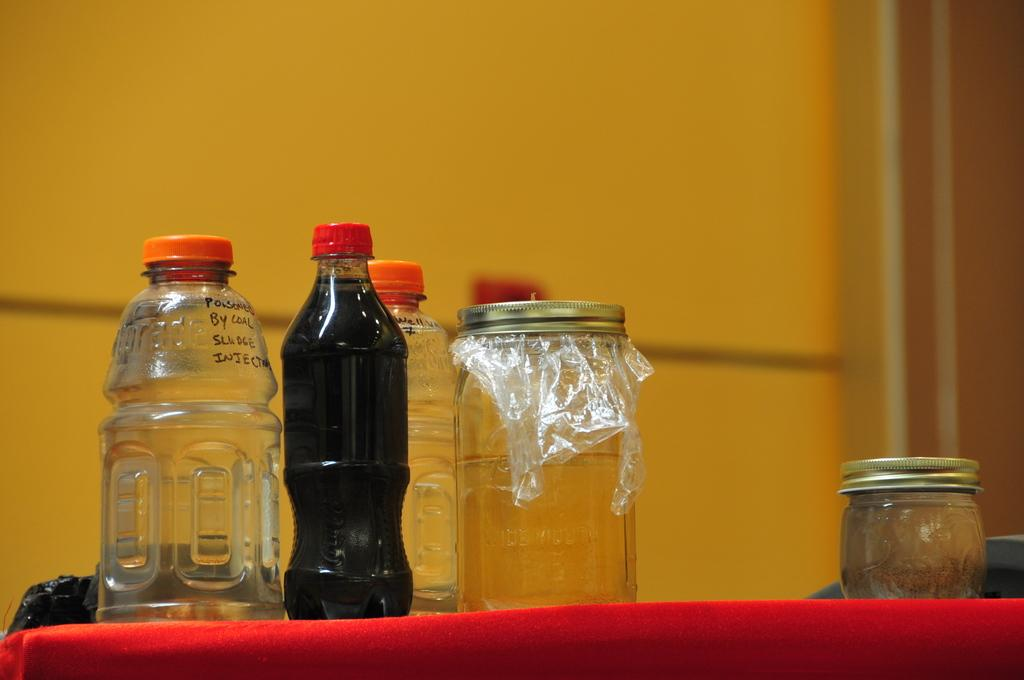<image>
Summarize the visual content of the image. Bottles and jars on a red covered table One marked "Poisoned by Coal Sludge..." 